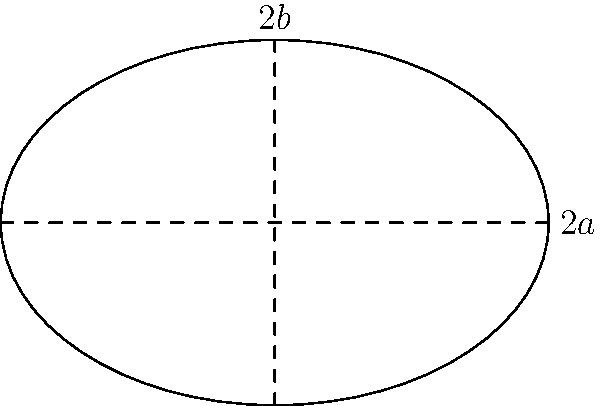In a biochemistry lab, you're studying a newly discovered ellipse-shaped organelle. The organelle's major axis is 6 μm and its minor axis is 4 μm. Calculate the approximate perimeter of this organelle using Ramanujan's formula for the perimeter of an ellipse: $P \approx \pi(a+b)\left(1 + \frac{3h}{10 + \sqrt{4-3h}}\right)$, where $h = \frac{(a-b)^2}{(a+b)^2}$, and $a$ and $b$ are the semi-major and semi-minor axes, respectively. Round your answer to the nearest 0.1 μm. Let's approach this step-by-step:

1) First, we need to identify $a$ and $b$:
   $a = 6/2 = 3$ μm (semi-major axis)
   $b = 4/2 = 2$ μm (semi-minor axis)

2) Now, let's calculate $h$:
   $h = \frac{(a-b)^2}{(a+b)^2} = \frac{(3-2)^2}{(3+2)^2} = \frac{1}{25} = 0.04$

3) We can now substitute these values into Ramanujan's formula:
   $P \approx \pi(a+b)\left(1 + \frac{3h}{10 + \sqrt{4-3h}}\right)$

4) Let's calculate the parts inside the parentheses first:
   $\sqrt{4-3h} = \sqrt{4-3(0.04)} = \sqrt{3.88} \approx 1.97$
   $\frac{3h}{10 + \sqrt{4-3h}} = \frac{3(0.04)}{10 + 1.97} \approx 0.01$

5) Now we can complete the calculation:
   $P \approx \pi(3+2)\left(1 + 0.01\right)$
   $P \approx 5\pi(1.01)$
   $P \approx 15.87$ μm

6) Rounding to the nearest 0.1 μm:
   $P \approx 15.9$ μm
Answer: 15.9 μm 